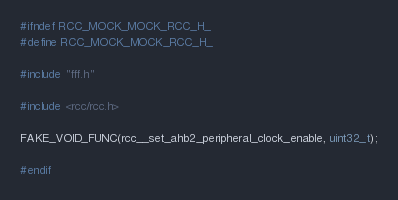Convert code to text. <code><loc_0><loc_0><loc_500><loc_500><_C_>#ifndef RCC_MOCK_MOCK_RCC_H_
#define RCC_MOCK_MOCK_RCC_H_

#include "fff.h"

#include <rcc/rcc.h>

FAKE_VOID_FUNC(rcc__set_ahb2_peripheral_clock_enable, uint32_t);

#endif
</code> 